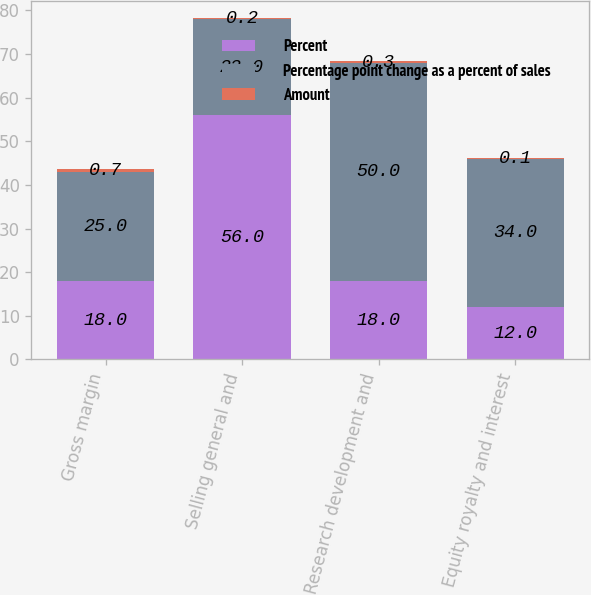Convert chart. <chart><loc_0><loc_0><loc_500><loc_500><stacked_bar_chart><ecel><fcel>Gross margin<fcel>Selling general and<fcel>Research development and<fcel>Equity royalty and interest<nl><fcel>Percent<fcel>18<fcel>56<fcel>18<fcel>12<nl><fcel>Percentage point change as a percent of sales<fcel>25<fcel>22<fcel>50<fcel>34<nl><fcel>Amount<fcel>0.7<fcel>0.2<fcel>0.3<fcel>0.1<nl></chart> 